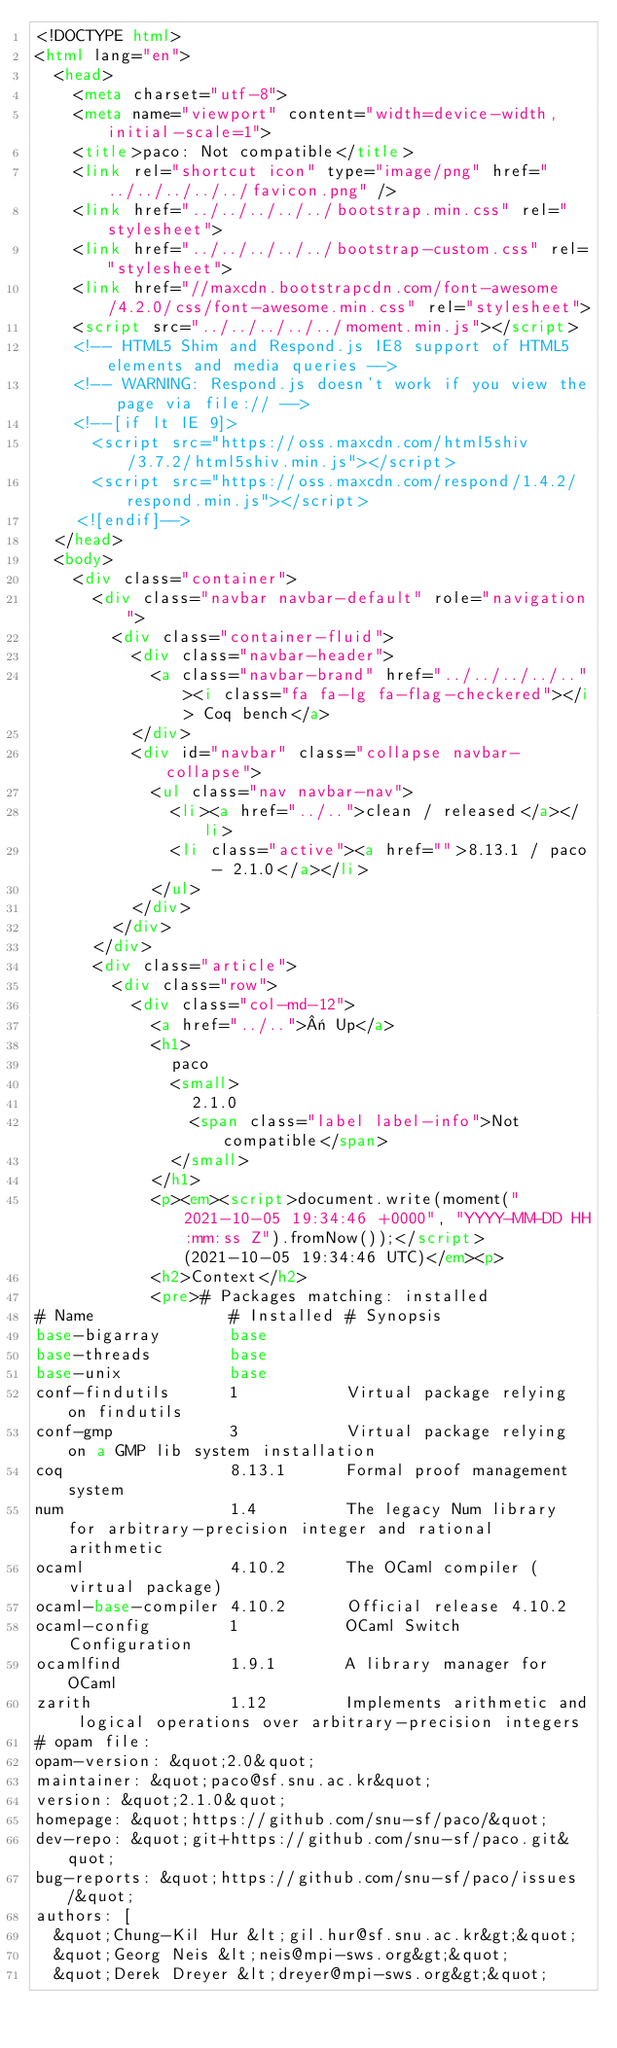<code> <loc_0><loc_0><loc_500><loc_500><_HTML_><!DOCTYPE html>
<html lang="en">
  <head>
    <meta charset="utf-8">
    <meta name="viewport" content="width=device-width, initial-scale=1">
    <title>paco: Not compatible</title>
    <link rel="shortcut icon" type="image/png" href="../../../../../favicon.png" />
    <link href="../../../../../bootstrap.min.css" rel="stylesheet">
    <link href="../../../../../bootstrap-custom.css" rel="stylesheet">
    <link href="//maxcdn.bootstrapcdn.com/font-awesome/4.2.0/css/font-awesome.min.css" rel="stylesheet">
    <script src="../../../../../moment.min.js"></script>
    <!-- HTML5 Shim and Respond.js IE8 support of HTML5 elements and media queries -->
    <!-- WARNING: Respond.js doesn't work if you view the page via file:// -->
    <!--[if lt IE 9]>
      <script src="https://oss.maxcdn.com/html5shiv/3.7.2/html5shiv.min.js"></script>
      <script src="https://oss.maxcdn.com/respond/1.4.2/respond.min.js"></script>
    <![endif]-->
  </head>
  <body>
    <div class="container">
      <div class="navbar navbar-default" role="navigation">
        <div class="container-fluid">
          <div class="navbar-header">
            <a class="navbar-brand" href="../../../../.."><i class="fa fa-lg fa-flag-checkered"></i> Coq bench</a>
          </div>
          <div id="navbar" class="collapse navbar-collapse">
            <ul class="nav navbar-nav">
              <li><a href="../..">clean / released</a></li>
              <li class="active"><a href="">8.13.1 / paco - 2.1.0</a></li>
            </ul>
          </div>
        </div>
      </div>
      <div class="article">
        <div class="row">
          <div class="col-md-12">
            <a href="../..">« Up</a>
            <h1>
              paco
              <small>
                2.1.0
                <span class="label label-info">Not compatible</span>
              </small>
            </h1>
            <p><em><script>document.write(moment("2021-10-05 19:34:46 +0000", "YYYY-MM-DD HH:mm:ss Z").fromNow());</script> (2021-10-05 19:34:46 UTC)</em><p>
            <h2>Context</h2>
            <pre># Packages matching: installed
# Name              # Installed # Synopsis
base-bigarray       base
base-threads        base
base-unix           base
conf-findutils      1           Virtual package relying on findutils
conf-gmp            3           Virtual package relying on a GMP lib system installation
coq                 8.13.1      Formal proof management system
num                 1.4         The legacy Num library for arbitrary-precision integer and rational arithmetic
ocaml               4.10.2      The OCaml compiler (virtual package)
ocaml-base-compiler 4.10.2      Official release 4.10.2
ocaml-config        1           OCaml Switch Configuration
ocamlfind           1.9.1       A library manager for OCaml
zarith              1.12        Implements arithmetic and logical operations over arbitrary-precision integers
# opam file:
opam-version: &quot;2.0&quot;
maintainer: &quot;paco@sf.snu.ac.kr&quot;
version: &quot;2.1.0&quot;
homepage: &quot;https://github.com/snu-sf/paco/&quot;
dev-repo: &quot;git+https://github.com/snu-sf/paco.git&quot;
bug-reports: &quot;https://github.com/snu-sf/paco/issues/&quot;
authors: [
  &quot;Chung-Kil Hur &lt;gil.hur@sf.snu.ac.kr&gt;&quot;
  &quot;Georg Neis &lt;neis@mpi-sws.org&gt;&quot;
  &quot;Derek Dreyer &lt;dreyer@mpi-sws.org&gt;&quot;</code> 